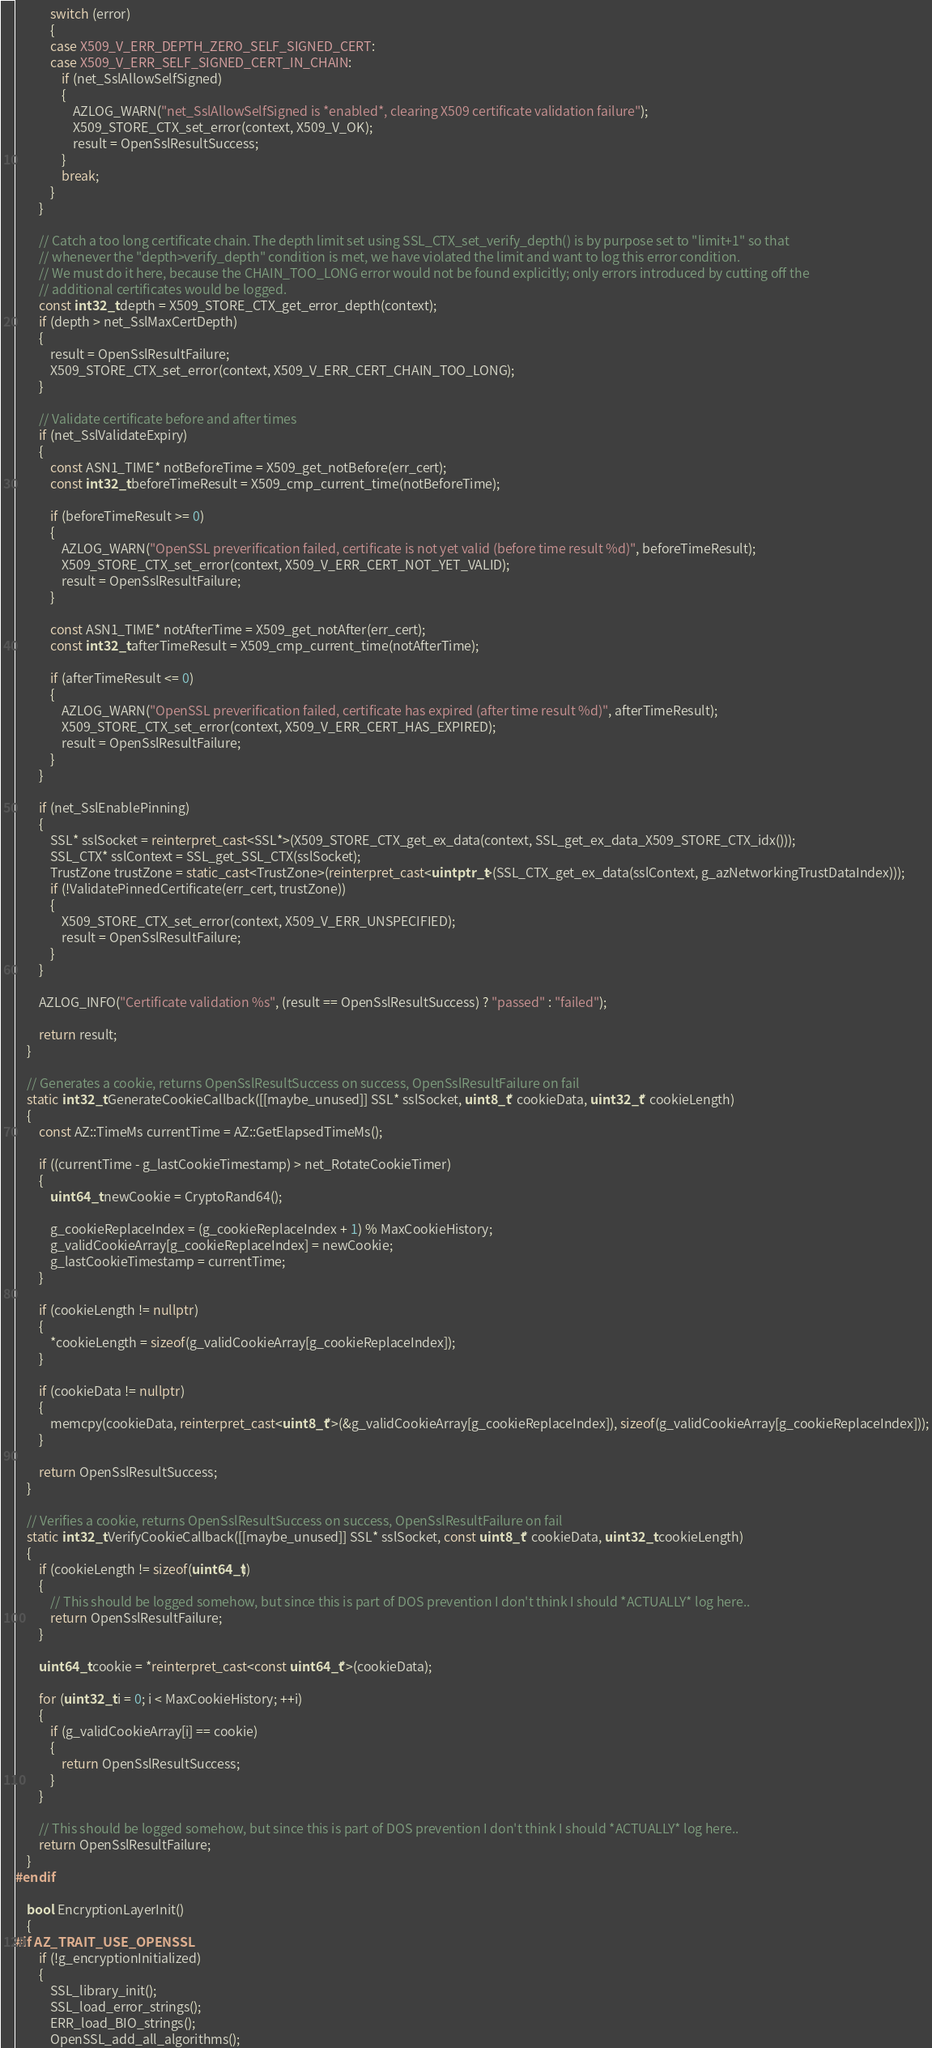<code> <loc_0><loc_0><loc_500><loc_500><_C++_>            switch (error)
            {
            case X509_V_ERR_DEPTH_ZERO_SELF_SIGNED_CERT:
            case X509_V_ERR_SELF_SIGNED_CERT_IN_CHAIN:
                if (net_SslAllowSelfSigned)
                {
                    AZLOG_WARN("net_SslAllowSelfSigned is *enabled*, clearing X509 certificate validation failure");
                    X509_STORE_CTX_set_error(context, X509_V_OK);
                    result = OpenSslResultSuccess;
                }
                break;
            }
        }

        // Catch a too long certificate chain. The depth limit set using SSL_CTX_set_verify_depth() is by purpose set to "limit+1" so that
        // whenever the "depth>verify_depth" condition is met, we have violated the limit and want to log this error condition.
        // We must do it here, because the CHAIN_TOO_LONG error would not be found explicitly; only errors introduced by cutting off the
        // additional certificates would be logged.
        const int32_t depth = X509_STORE_CTX_get_error_depth(context);
        if (depth > net_SslMaxCertDepth)
        {
            result = OpenSslResultFailure;
            X509_STORE_CTX_set_error(context, X509_V_ERR_CERT_CHAIN_TOO_LONG);
        }

        // Validate certificate before and after times
        if (net_SslValidateExpiry)
        {
            const ASN1_TIME* notBeforeTime = X509_get_notBefore(err_cert);
            const int32_t beforeTimeResult = X509_cmp_current_time(notBeforeTime);

            if (beforeTimeResult >= 0)
            {
                AZLOG_WARN("OpenSSL preverification failed, certificate is not yet valid (before time result %d)", beforeTimeResult);
                X509_STORE_CTX_set_error(context, X509_V_ERR_CERT_NOT_YET_VALID);
                result = OpenSslResultFailure;
            }

            const ASN1_TIME* notAfterTime = X509_get_notAfter(err_cert);
            const int32_t afterTimeResult = X509_cmp_current_time(notAfterTime);

            if (afterTimeResult <= 0)
            {
                AZLOG_WARN("OpenSSL preverification failed, certificate has expired (after time result %d)", afterTimeResult);
                X509_STORE_CTX_set_error(context, X509_V_ERR_CERT_HAS_EXPIRED);
                result = OpenSslResultFailure;
            }
        }

        if (net_SslEnablePinning)
        {
            SSL* sslSocket = reinterpret_cast<SSL*>(X509_STORE_CTX_get_ex_data(context, SSL_get_ex_data_X509_STORE_CTX_idx()));
            SSL_CTX* sslContext = SSL_get_SSL_CTX(sslSocket);
            TrustZone trustZone = static_cast<TrustZone>(reinterpret_cast<uintptr_t>(SSL_CTX_get_ex_data(sslContext, g_azNetworkingTrustDataIndex)));
            if (!ValidatePinnedCertificate(err_cert, trustZone))
            {
                X509_STORE_CTX_set_error(context, X509_V_ERR_UNSPECIFIED);
                result = OpenSslResultFailure;
            }
        }

        AZLOG_INFO("Certificate validation %s", (result == OpenSslResultSuccess) ? "passed" : "failed");

        return result;
    }

    // Generates a cookie, returns OpenSslResultSuccess on success, OpenSslResultFailure on fail
    static int32_t GenerateCookieCallback([[maybe_unused]] SSL* sslSocket, uint8_t* cookieData, uint32_t* cookieLength)
    {
        const AZ::TimeMs currentTime = AZ::GetElapsedTimeMs();

        if ((currentTime - g_lastCookieTimestamp) > net_RotateCookieTimer)
        {
            uint64_t newCookie = CryptoRand64();

            g_cookieReplaceIndex = (g_cookieReplaceIndex + 1) % MaxCookieHistory;
            g_validCookieArray[g_cookieReplaceIndex] = newCookie;
            g_lastCookieTimestamp = currentTime;
        }

        if (cookieLength != nullptr)
        {
            *cookieLength = sizeof(g_validCookieArray[g_cookieReplaceIndex]);
        }

        if (cookieData != nullptr)
        {
            memcpy(cookieData, reinterpret_cast<uint8_t*>(&g_validCookieArray[g_cookieReplaceIndex]), sizeof(g_validCookieArray[g_cookieReplaceIndex]));
        }

        return OpenSslResultSuccess;
    }

    // Verifies a cookie, returns OpenSslResultSuccess on success, OpenSslResultFailure on fail
    static int32_t VerifyCookieCallback([[maybe_unused]] SSL* sslSocket, const uint8_t* cookieData, uint32_t cookieLength)
    {
        if (cookieLength != sizeof(uint64_t))
        {
            // This should be logged somehow, but since this is part of DOS prevention I don't think I should *ACTUALLY* log here..
            return OpenSslResultFailure;
        }

        uint64_t cookie = *reinterpret_cast<const uint64_t*>(cookieData);

        for (uint32_t i = 0; i < MaxCookieHistory; ++i)
        {
            if (g_validCookieArray[i] == cookie)
            {
                return OpenSslResultSuccess;
            }
        }

        // This should be logged somehow, but since this is part of DOS prevention I don't think I should *ACTUALLY* log here..
        return OpenSslResultFailure;
    }
#endif

    bool EncryptionLayerInit()
    {
#if AZ_TRAIT_USE_OPENSSL
        if (!g_encryptionInitialized)
        {
            SSL_library_init();
            SSL_load_error_strings();
            ERR_load_BIO_strings();
            OpenSSL_add_all_algorithms();</code> 